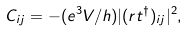<formula> <loc_0><loc_0><loc_500><loc_500>C _ { i j } = - ( e ^ { 3 } V / h ) | ( r t ^ { \dagger } ) _ { i j } | ^ { 2 } ,</formula> 